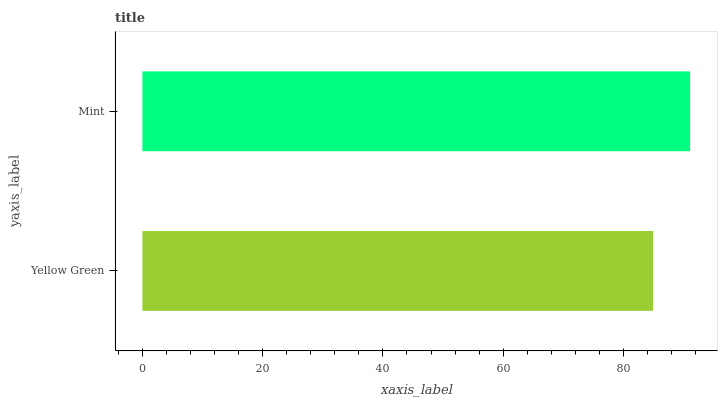Is Yellow Green the minimum?
Answer yes or no. Yes. Is Mint the maximum?
Answer yes or no. Yes. Is Mint the minimum?
Answer yes or no. No. Is Mint greater than Yellow Green?
Answer yes or no. Yes. Is Yellow Green less than Mint?
Answer yes or no. Yes. Is Yellow Green greater than Mint?
Answer yes or no. No. Is Mint less than Yellow Green?
Answer yes or no. No. Is Mint the high median?
Answer yes or no. Yes. Is Yellow Green the low median?
Answer yes or no. Yes. Is Yellow Green the high median?
Answer yes or no. No. Is Mint the low median?
Answer yes or no. No. 